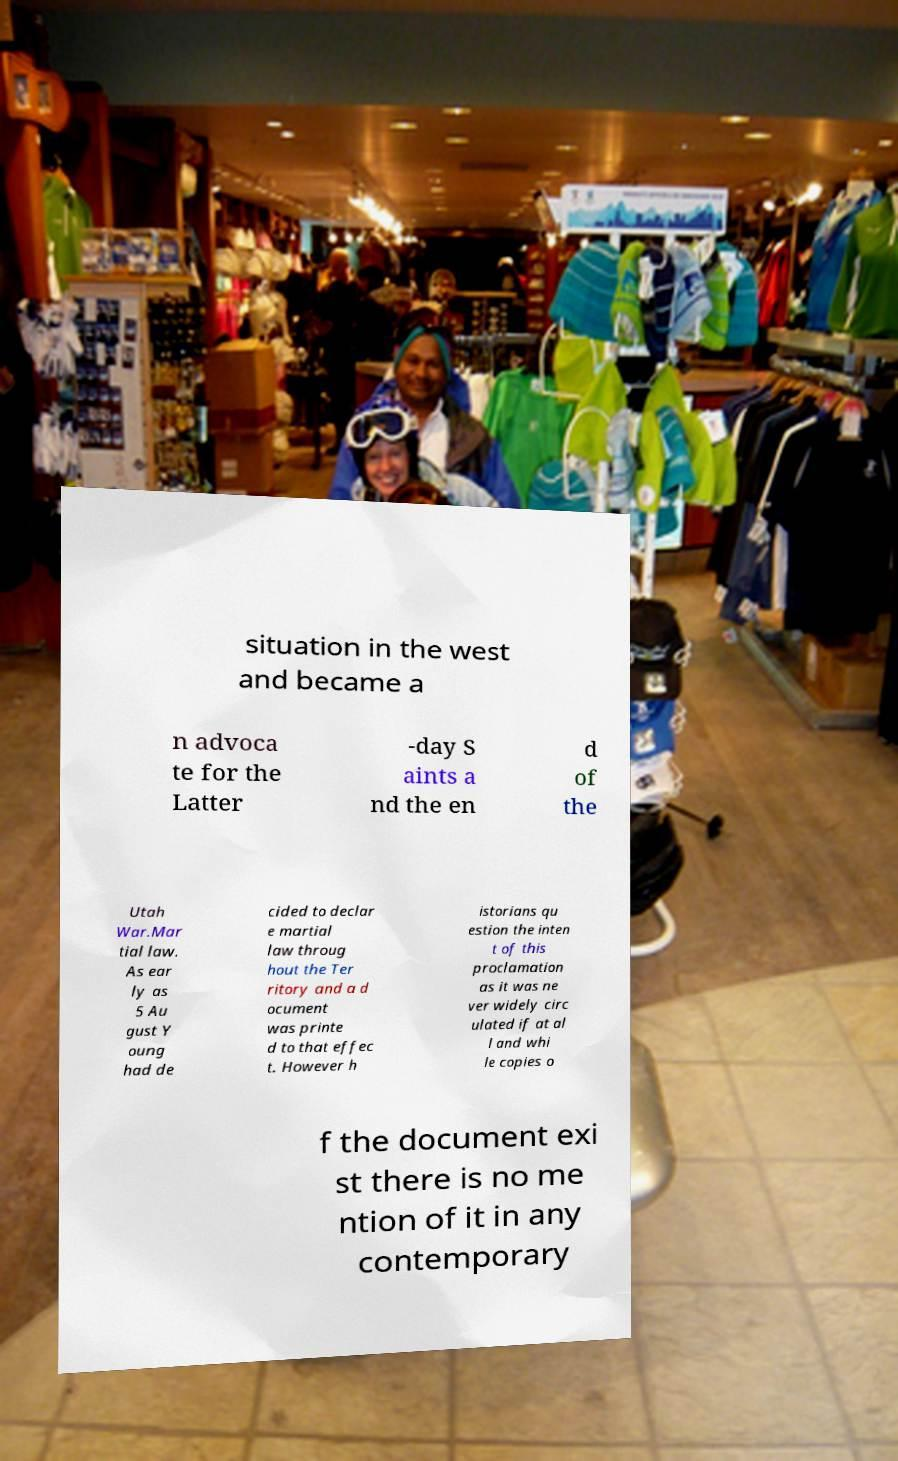For documentation purposes, I need the text within this image transcribed. Could you provide that? situation in the west and became a n advoca te for the Latter -day S aints a nd the en d of the Utah War.Mar tial law. As ear ly as 5 Au gust Y oung had de cided to declar e martial law throug hout the Ter ritory and a d ocument was printe d to that effec t. However h istorians qu estion the inten t of this proclamation as it was ne ver widely circ ulated if at al l and whi le copies o f the document exi st there is no me ntion of it in any contemporary 